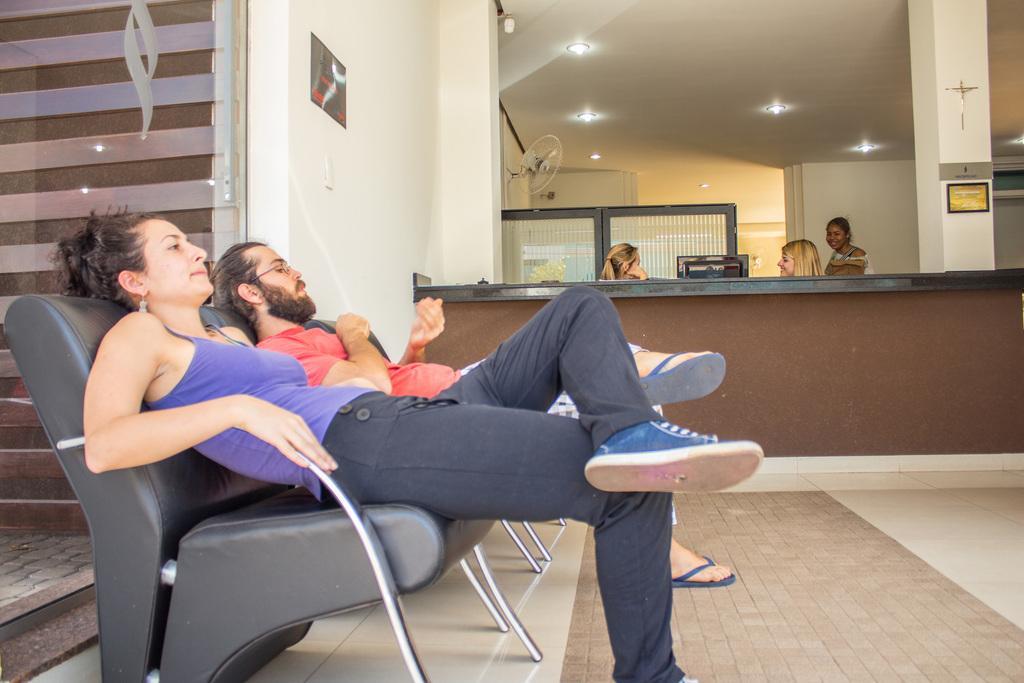Could you give a brief overview of what you see in this image? In the image there are five people. Two people both men and women are sitting on chairs remaining three people are behind the table. On left side we can see a board,switch board,fan. On right side we can see a pillar on top we can see few lights. 